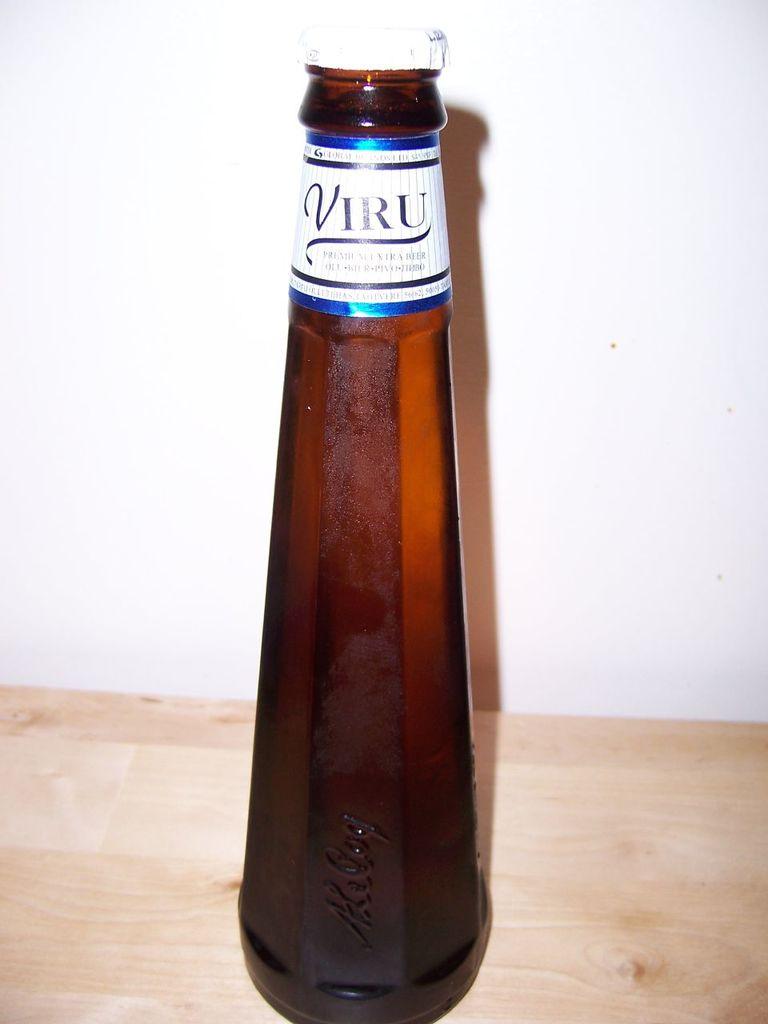Is this a beer or water brand ?
Your answer should be compact. Beer. What brand is this beverage?
Make the answer very short. Viru. 